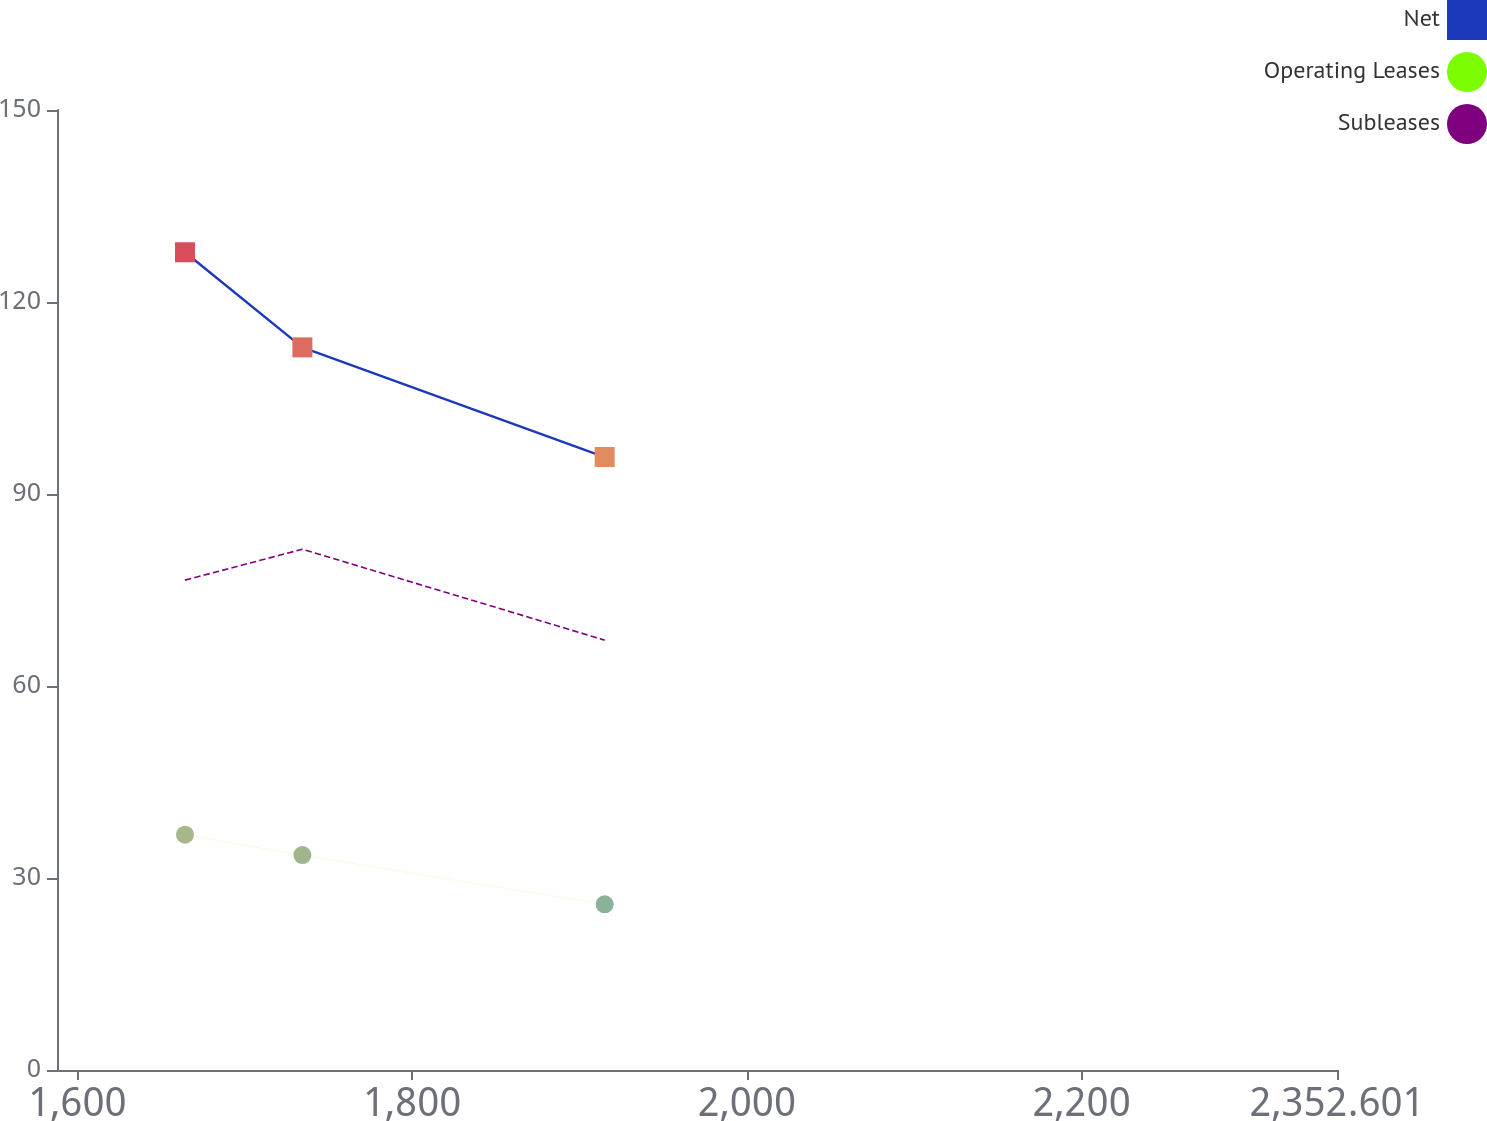Convert chart. <chart><loc_0><loc_0><loc_500><loc_500><line_chart><ecel><fcel>Net<fcel>Operating Leases<fcel>Subleases<nl><fcel>1664.29<fcel>127.77<fcel>36.77<fcel>76.54<nl><fcel>1734.42<fcel>112.91<fcel>33.58<fcel>81.37<nl><fcel>1915.04<fcel>95.78<fcel>25.89<fcel>67.17<nl><fcel>2358.95<fcel>44.24<fcel>7.1<fcel>55.93<nl><fcel>2429.08<fcel>31.4<fcel>1.73<fcel>30.92<nl></chart> 